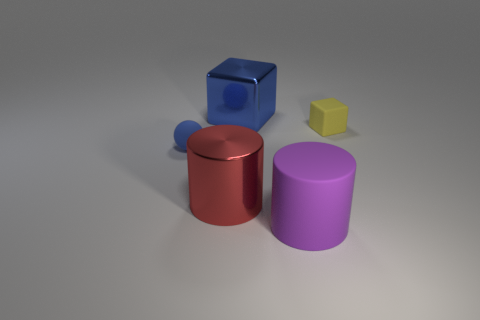Is there anything else of the same color as the large metallic cylinder?
Ensure brevity in your answer.  No. What size is the purple object that is the same material as the ball?
Provide a short and direct response. Large. What is the red object made of?
Your answer should be compact. Metal. How many red things have the same size as the rubber block?
Make the answer very short. 0. What is the shape of the thing that is the same color as the matte ball?
Your answer should be compact. Cube. Are there any yellow rubber things that have the same shape as the purple matte thing?
Provide a succinct answer. No. There is a rubber object that is the same size as the yellow matte block; what is its color?
Offer a very short reply. Blue. What is the color of the small thing behind the small matte thing in front of the small yellow matte object?
Your response must be concise. Yellow. Does the large metal object behind the small yellow matte thing have the same color as the ball?
Your answer should be compact. Yes. The small matte thing that is left of the small object that is on the right side of the tiny object on the left side of the big red cylinder is what shape?
Offer a very short reply. Sphere. 